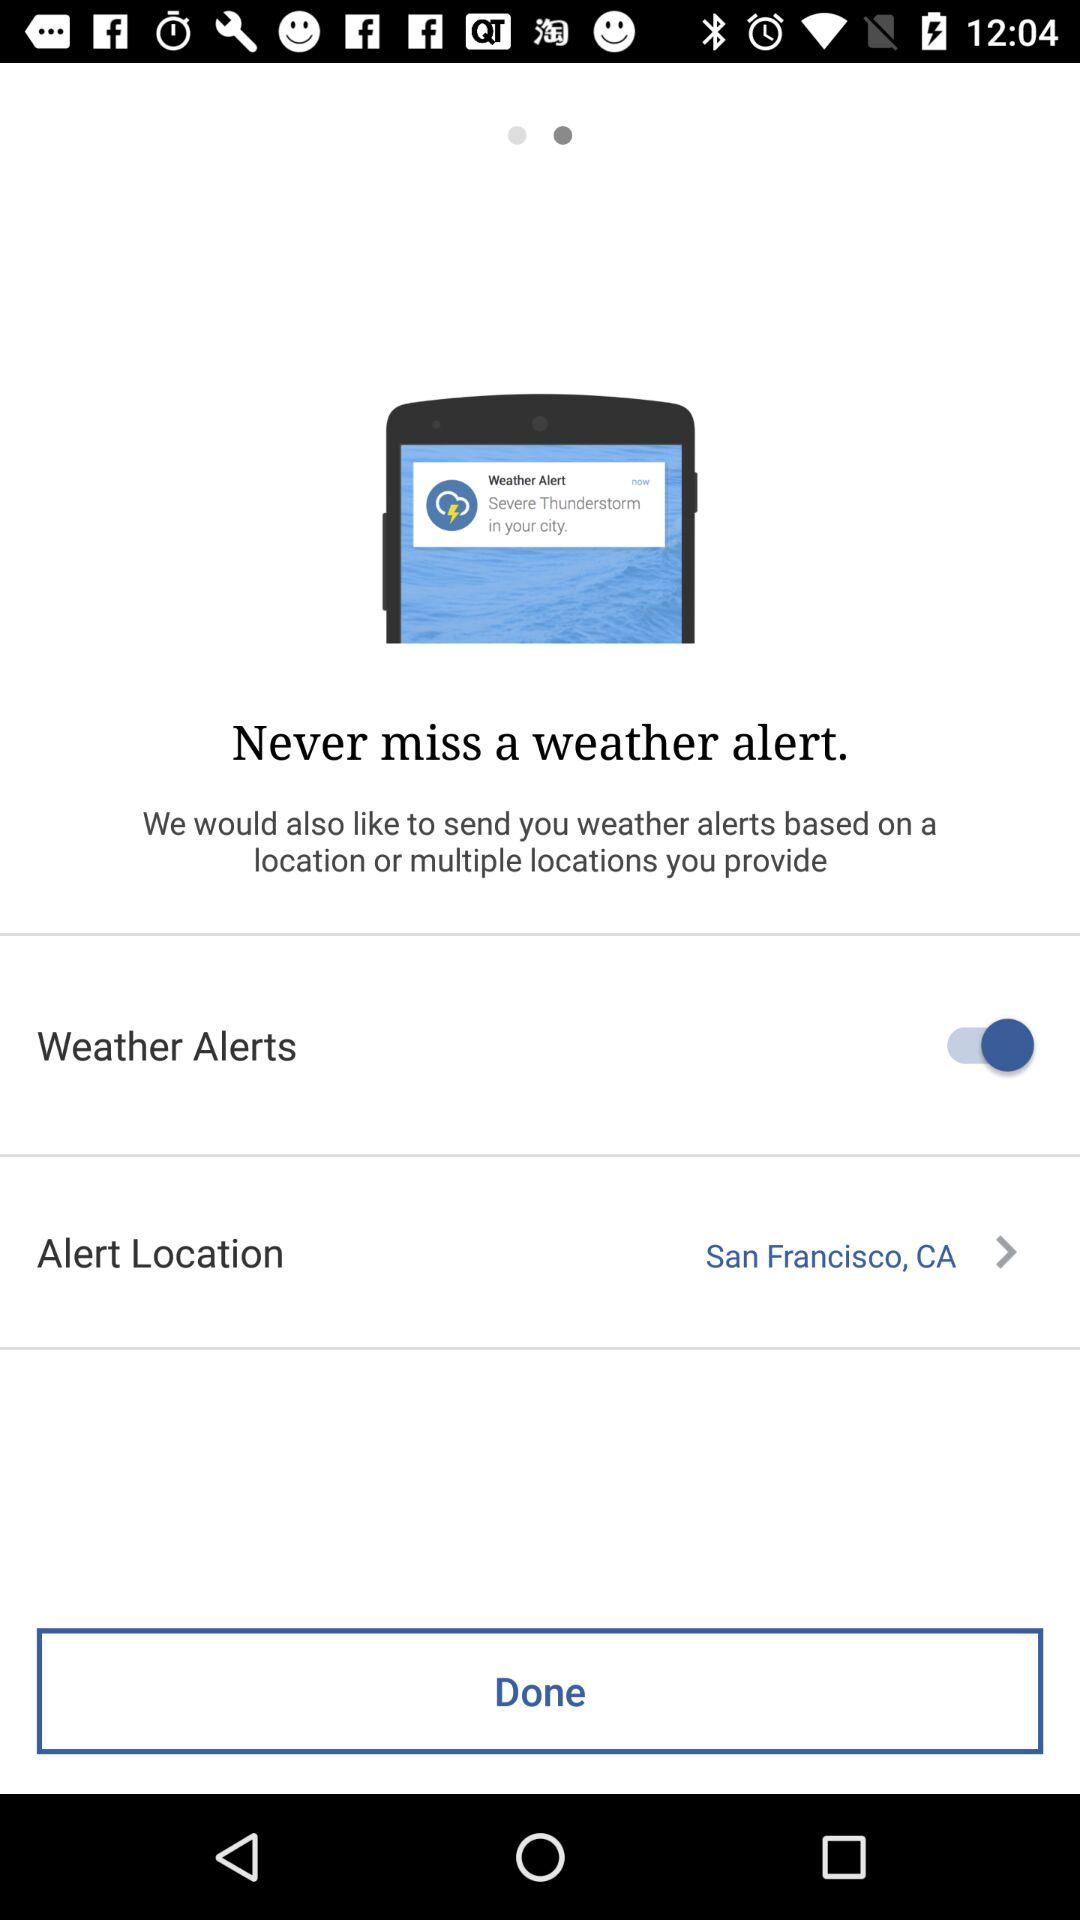What is the alert location? The alert location is San Francisco, California. 